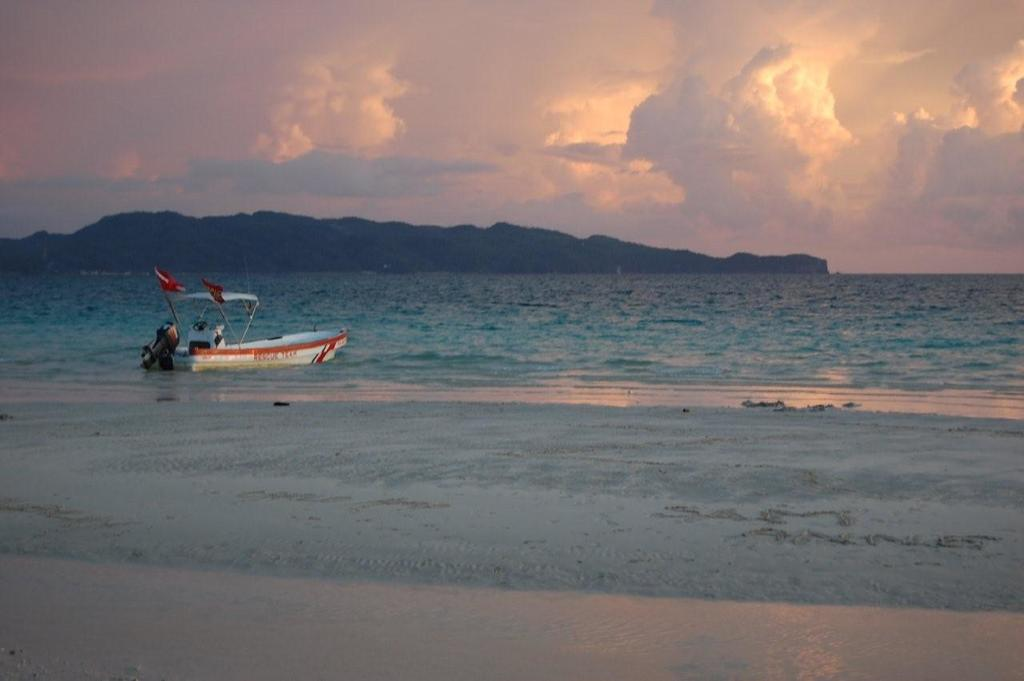What is the main subject of the image? The main subject of the image is a boat. Where is the boat located? The boat is on the water. What else can be seen in the image besides the boat? There are flags, mountains, and the sky visible in the image. What is the condition of the sky in the image? The sky is visible in the background of the image, and clouds are present. How many pairs of shoes can be seen on the boat in the image? There are no shoes visible in the image; it features a boat on the water with flags, mountains, and a sky with clouds. Can you hear the monkey in the image? There is no monkey present in the image, so it is not possible to hear one. 